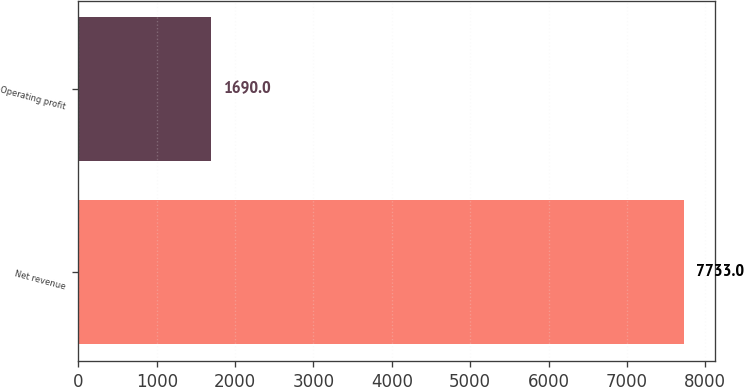Convert chart. <chart><loc_0><loc_0><loc_500><loc_500><bar_chart><fcel>Net revenue<fcel>Operating profit<nl><fcel>7733<fcel>1690<nl></chart> 